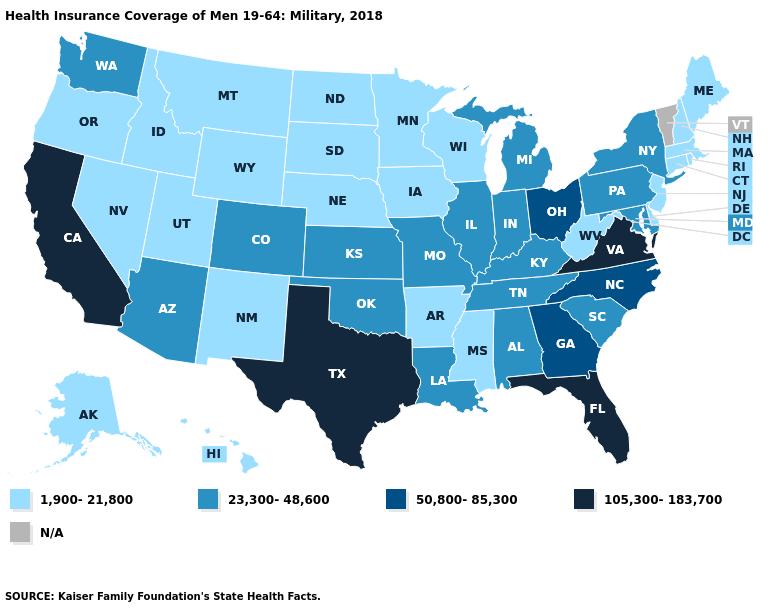What is the value of Alaska?
Keep it brief. 1,900-21,800. What is the value of Hawaii?
Concise answer only. 1,900-21,800. What is the highest value in states that border Washington?
Be succinct. 1,900-21,800. Which states have the lowest value in the USA?
Short answer required. Alaska, Arkansas, Connecticut, Delaware, Hawaii, Idaho, Iowa, Maine, Massachusetts, Minnesota, Mississippi, Montana, Nebraska, Nevada, New Hampshire, New Jersey, New Mexico, North Dakota, Oregon, Rhode Island, South Dakota, Utah, West Virginia, Wisconsin, Wyoming. Which states have the lowest value in the USA?
Keep it brief. Alaska, Arkansas, Connecticut, Delaware, Hawaii, Idaho, Iowa, Maine, Massachusetts, Minnesota, Mississippi, Montana, Nebraska, Nevada, New Hampshire, New Jersey, New Mexico, North Dakota, Oregon, Rhode Island, South Dakota, Utah, West Virginia, Wisconsin, Wyoming. What is the value of Florida?
Write a very short answer. 105,300-183,700. Does Massachusetts have the lowest value in the USA?
Quick response, please. Yes. What is the value of Mississippi?
Quick response, please. 1,900-21,800. Name the states that have a value in the range 23,300-48,600?
Quick response, please. Alabama, Arizona, Colorado, Illinois, Indiana, Kansas, Kentucky, Louisiana, Maryland, Michigan, Missouri, New York, Oklahoma, Pennsylvania, South Carolina, Tennessee, Washington. Does North Carolina have the highest value in the USA?
Give a very brief answer. No. Name the states that have a value in the range 50,800-85,300?
Short answer required. Georgia, North Carolina, Ohio. Name the states that have a value in the range 105,300-183,700?
Give a very brief answer. California, Florida, Texas, Virginia. Among the states that border Massachusetts , does New York have the highest value?
Give a very brief answer. Yes. Which states have the highest value in the USA?
Short answer required. California, Florida, Texas, Virginia. What is the value of Massachusetts?
Short answer required. 1,900-21,800. 